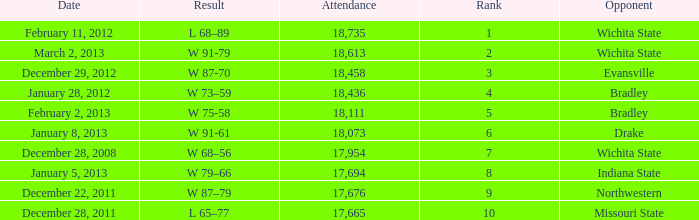What's the rank for February 11, 2012 with less than 18,735 in attendance? None. 